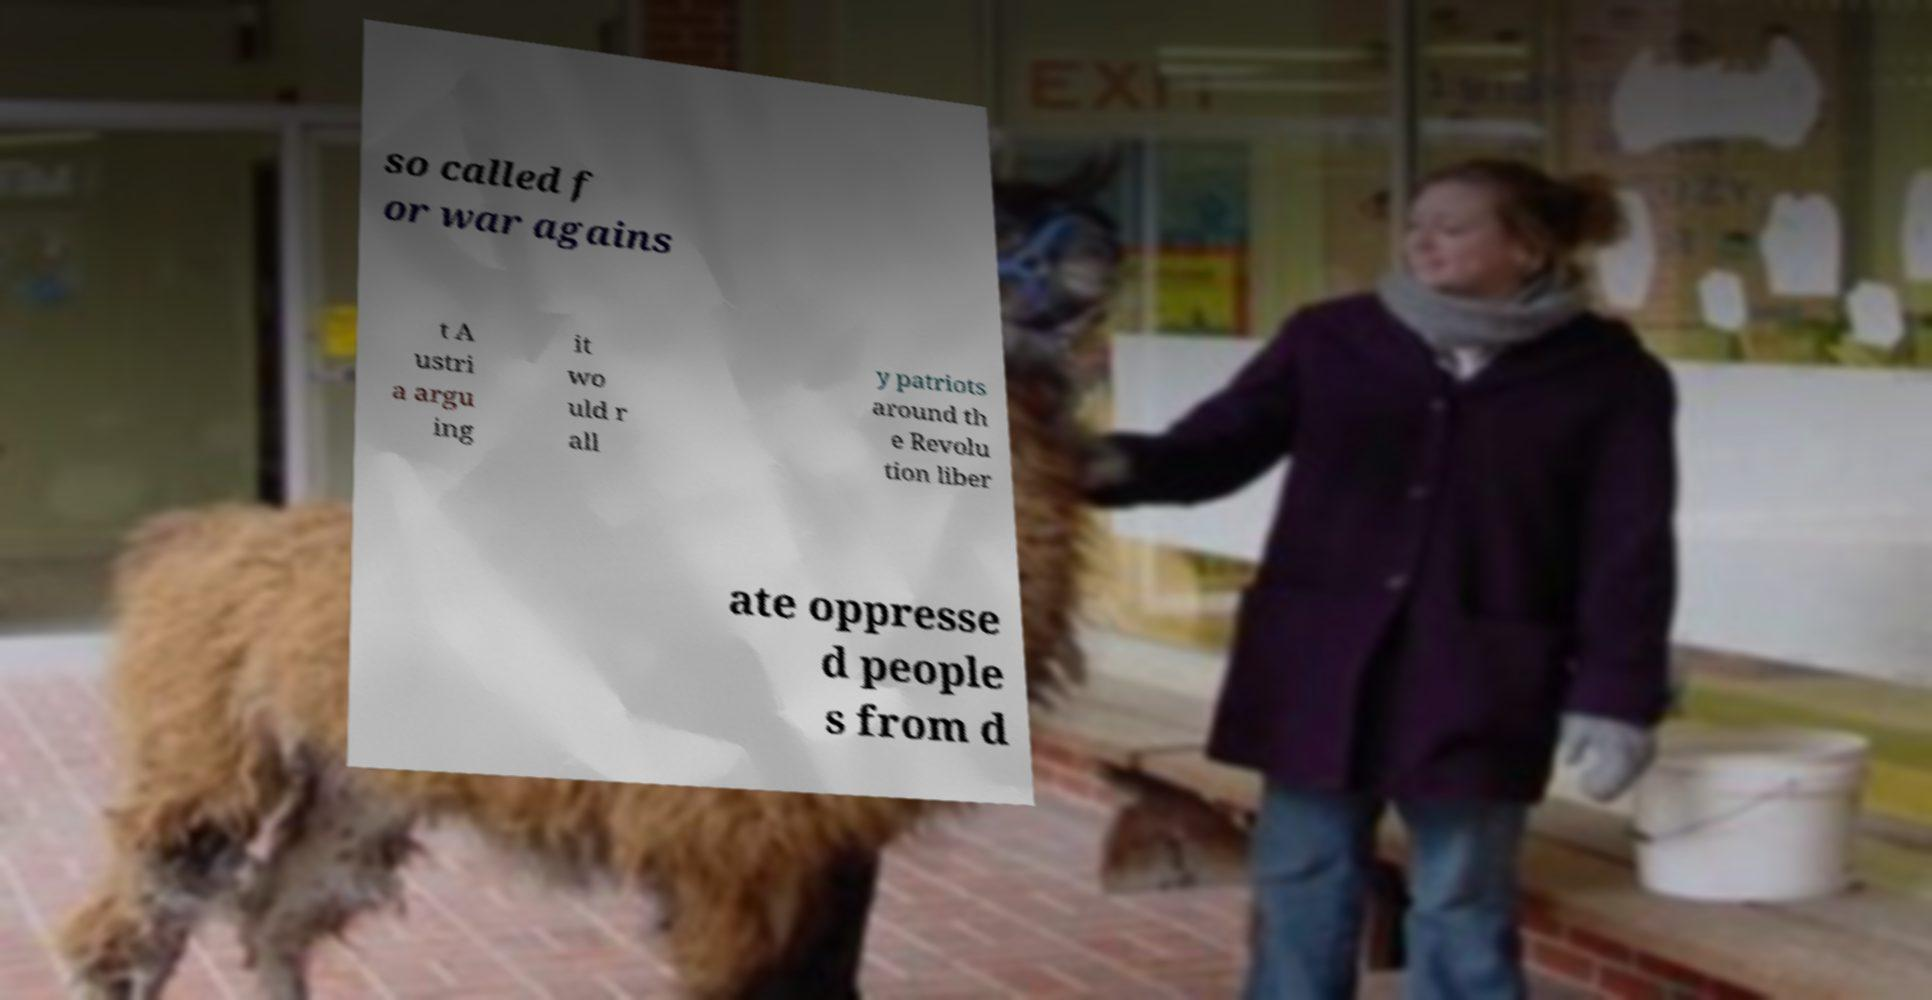What messages or text are displayed in this image? I need them in a readable, typed format. so called f or war agains t A ustri a argu ing it wo uld r all y patriots around th e Revolu tion liber ate oppresse d people s from d 